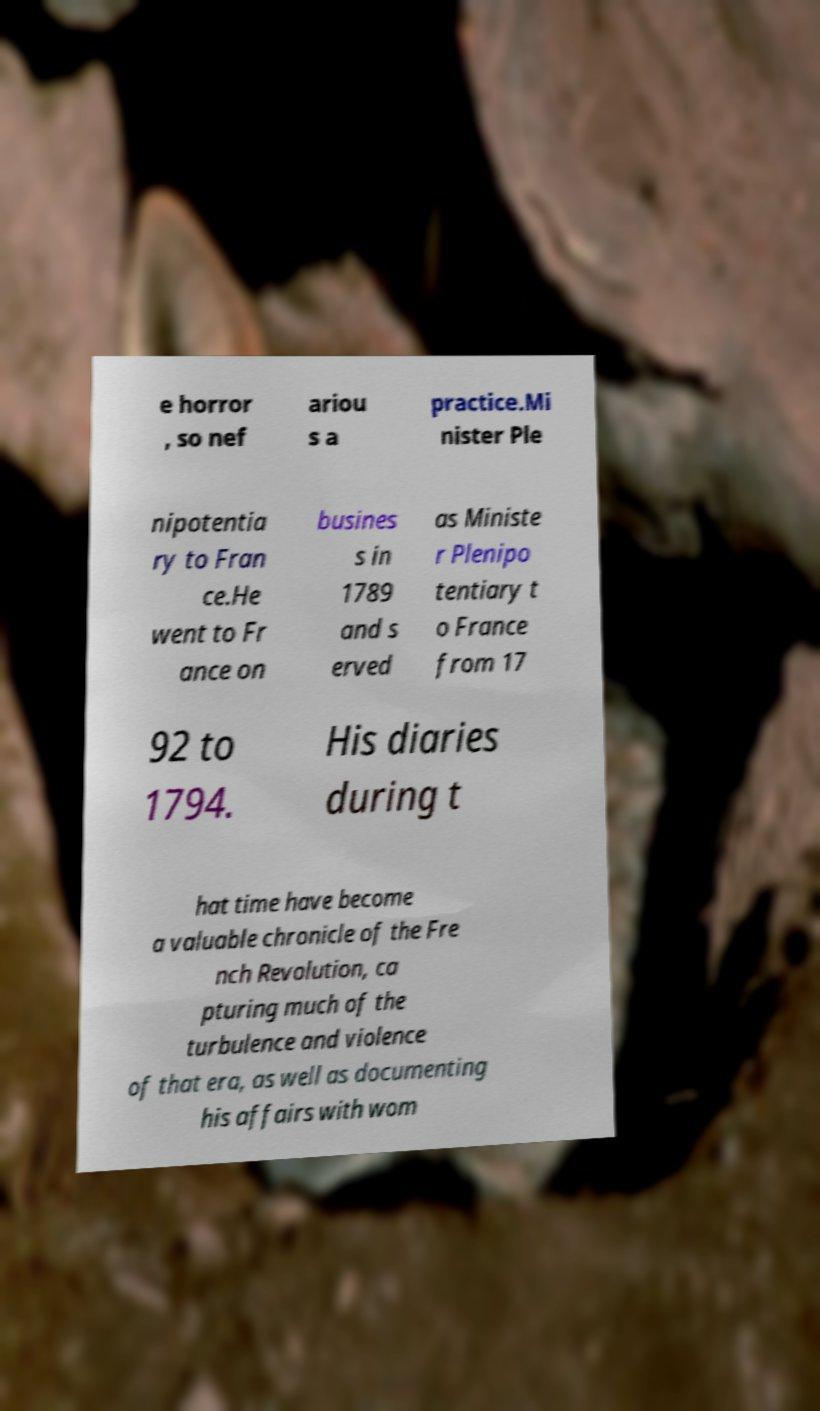Please identify and transcribe the text found in this image. e horror , so nef ariou s a practice.Mi nister Ple nipotentia ry to Fran ce.He went to Fr ance on busines s in 1789 and s erved as Ministe r Plenipo tentiary t o France from 17 92 to 1794. His diaries during t hat time have become a valuable chronicle of the Fre nch Revolution, ca pturing much of the turbulence and violence of that era, as well as documenting his affairs with wom 